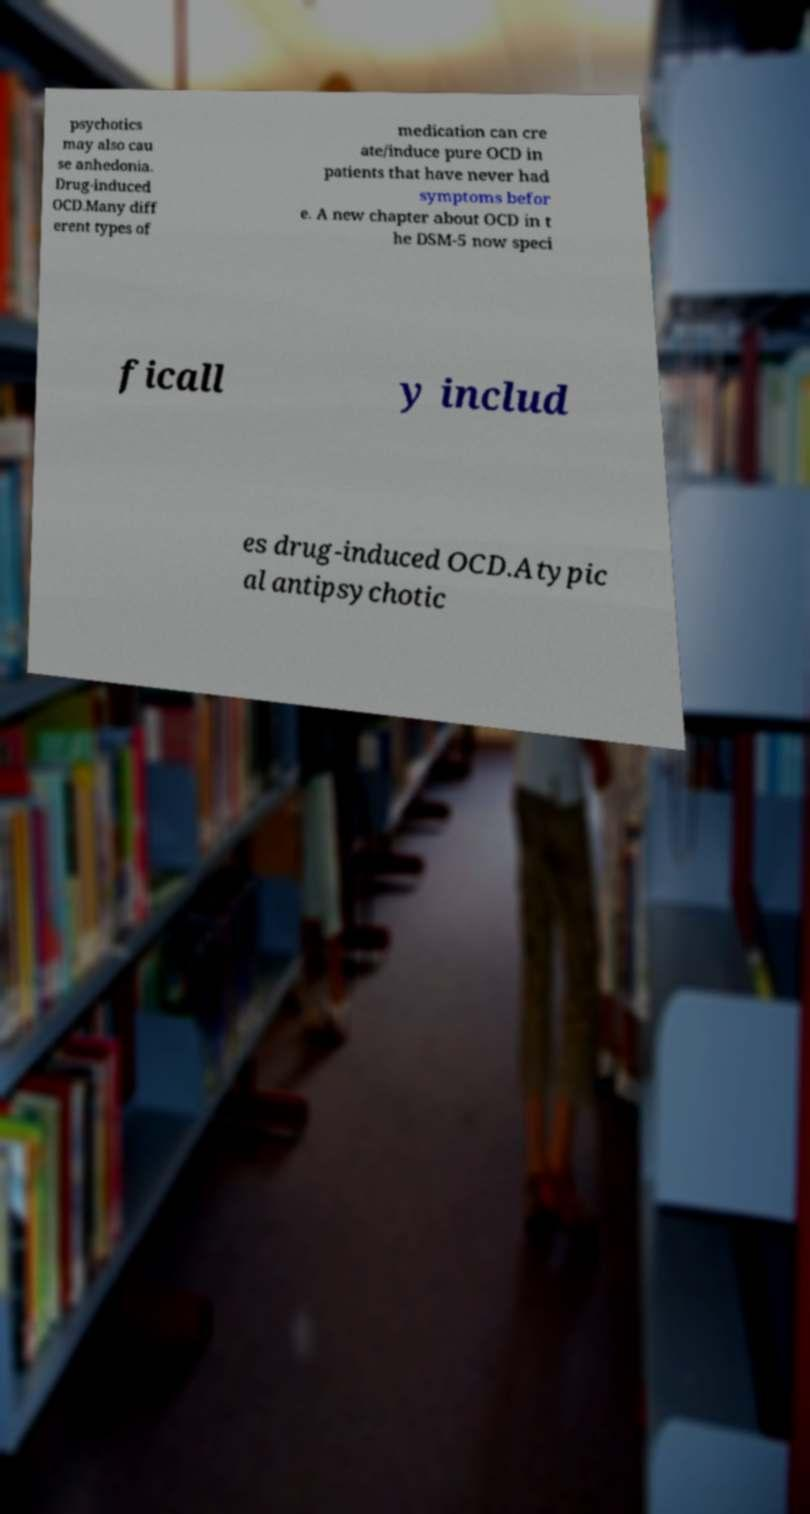Can you read and provide the text displayed in the image?This photo seems to have some interesting text. Can you extract and type it out for me? psychotics may also cau se anhedonia. Drug-induced OCD.Many diff erent types of medication can cre ate/induce pure OCD in patients that have never had symptoms befor e. A new chapter about OCD in t he DSM-5 now speci ficall y includ es drug-induced OCD.Atypic al antipsychotic 